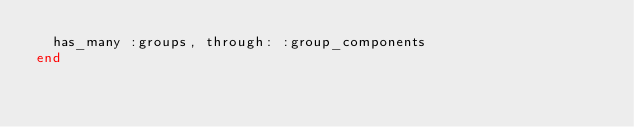Convert code to text. <code><loc_0><loc_0><loc_500><loc_500><_Ruby_>  has_many :groups, through: :group_components
end
</code> 